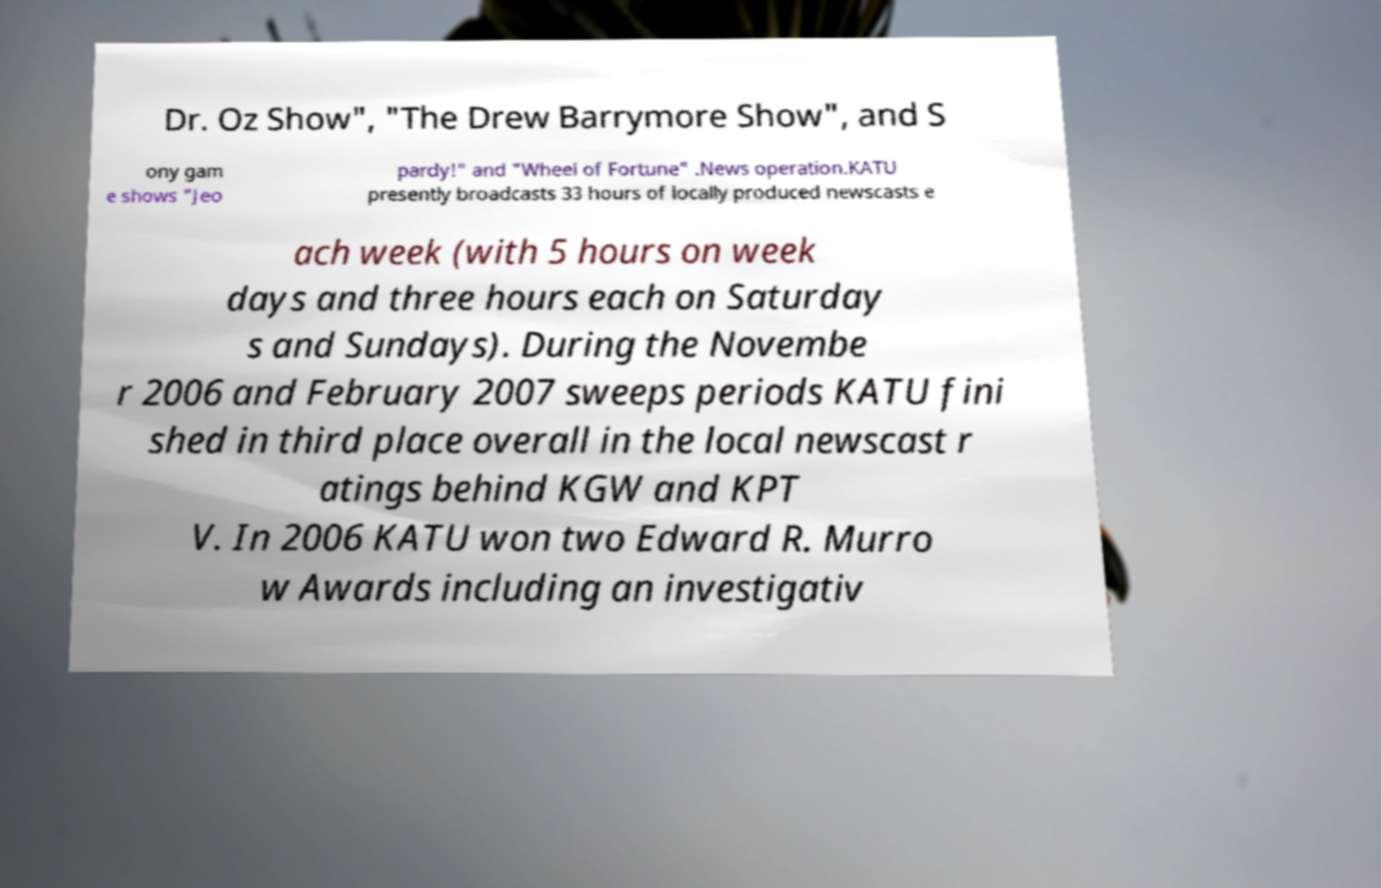Please identify and transcribe the text found in this image. Dr. Oz Show", "The Drew Barrymore Show", and S ony gam e shows "Jeo pardy!" and "Wheel of Fortune" .News operation.KATU presently broadcasts 33 hours of locally produced newscasts e ach week (with 5 hours on week days and three hours each on Saturday s and Sundays). During the Novembe r 2006 and February 2007 sweeps periods KATU fini shed in third place overall in the local newscast r atings behind KGW and KPT V. In 2006 KATU won two Edward R. Murro w Awards including an investigativ 